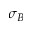<formula> <loc_0><loc_0><loc_500><loc_500>\sigma _ { B }</formula> 